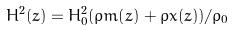Convert formula to latex. <formula><loc_0><loc_0><loc_500><loc_500>H ^ { 2 } ( z ) = H _ { 0 } ^ { 2 } ( \rho m ( z ) + \rho x ( z ) ) / \rho _ { 0 }</formula> 